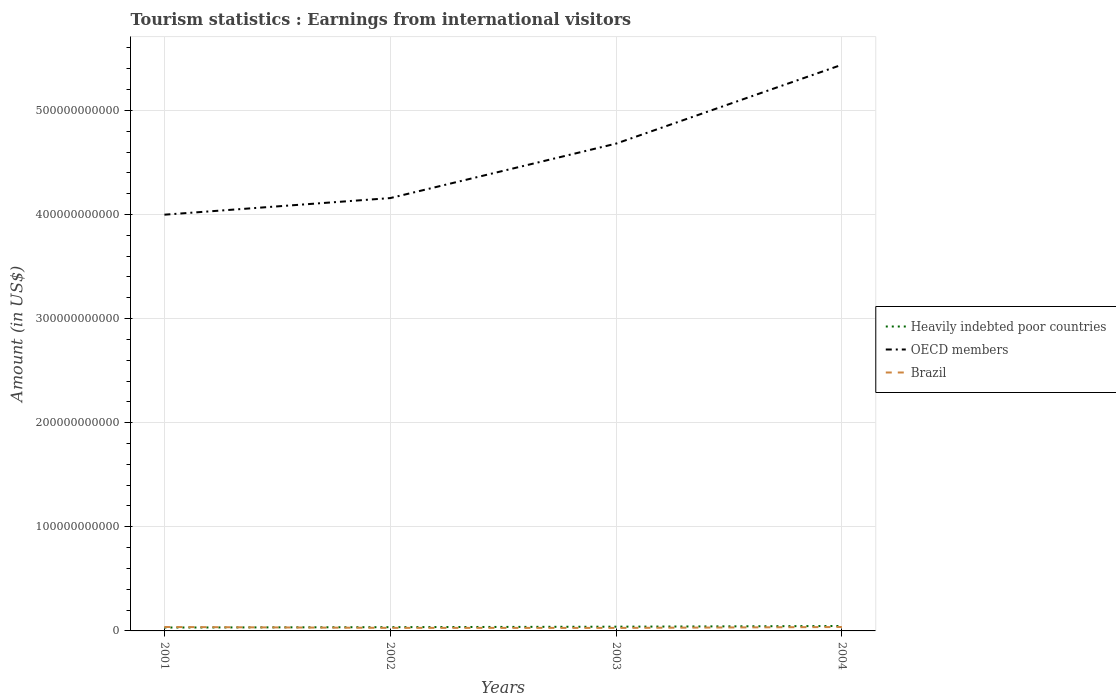How many different coloured lines are there?
Keep it short and to the point. 3. Does the line corresponding to Heavily indebted poor countries intersect with the line corresponding to Brazil?
Keep it short and to the point. Yes. Is the number of lines equal to the number of legend labels?
Your response must be concise. Yes. Across all years, what is the maximum earnings from international visitors in OECD members?
Give a very brief answer. 4.00e+11. What is the total earnings from international visitors in Heavily indebted poor countries in the graph?
Make the answer very short. -6.52e+08. What is the difference between the highest and the second highest earnings from international visitors in OECD members?
Your answer should be very brief. 1.44e+11. Is the earnings from international visitors in Brazil strictly greater than the earnings from international visitors in Heavily indebted poor countries over the years?
Your response must be concise. No. How many years are there in the graph?
Make the answer very short. 4. What is the difference between two consecutive major ticks on the Y-axis?
Offer a very short reply. 1.00e+11. Does the graph contain any zero values?
Your response must be concise. No. How many legend labels are there?
Keep it short and to the point. 3. What is the title of the graph?
Your answer should be compact. Tourism statistics : Earnings from international visitors. What is the label or title of the Y-axis?
Provide a succinct answer. Amount (in US$). What is the Amount (in US$) of Heavily indebted poor countries in 2001?
Your answer should be compact. 3.25e+09. What is the Amount (in US$) in OECD members in 2001?
Your answer should be very brief. 4.00e+11. What is the Amount (in US$) of Brazil in 2001?
Give a very brief answer. 3.76e+09. What is the Amount (in US$) in Heavily indebted poor countries in 2002?
Offer a terse response. 3.61e+09. What is the Amount (in US$) in OECD members in 2002?
Provide a short and direct response. 4.16e+11. What is the Amount (in US$) of Brazil in 2002?
Ensure brevity in your answer.  2.93e+09. What is the Amount (in US$) in Heavily indebted poor countries in 2003?
Your response must be concise. 4.07e+09. What is the Amount (in US$) of OECD members in 2003?
Your answer should be compact. 4.68e+11. What is the Amount (in US$) of Brazil in 2003?
Give a very brief answer. 2.87e+09. What is the Amount (in US$) in Heavily indebted poor countries in 2004?
Your answer should be compact. 4.72e+09. What is the Amount (in US$) of OECD members in 2004?
Your answer should be compact. 5.44e+11. What is the Amount (in US$) of Brazil in 2004?
Make the answer very short. 3.75e+09. Across all years, what is the maximum Amount (in US$) in Heavily indebted poor countries?
Provide a succinct answer. 4.72e+09. Across all years, what is the maximum Amount (in US$) of OECD members?
Give a very brief answer. 5.44e+11. Across all years, what is the maximum Amount (in US$) in Brazil?
Offer a terse response. 3.76e+09. Across all years, what is the minimum Amount (in US$) in Heavily indebted poor countries?
Give a very brief answer. 3.25e+09. Across all years, what is the minimum Amount (in US$) of OECD members?
Offer a terse response. 4.00e+11. Across all years, what is the minimum Amount (in US$) in Brazil?
Offer a very short reply. 2.87e+09. What is the total Amount (in US$) of Heavily indebted poor countries in the graph?
Your answer should be very brief. 1.57e+1. What is the total Amount (in US$) of OECD members in the graph?
Provide a short and direct response. 1.83e+12. What is the total Amount (in US$) in Brazil in the graph?
Offer a terse response. 1.33e+1. What is the difference between the Amount (in US$) of Heavily indebted poor countries in 2001 and that in 2002?
Provide a short and direct response. -3.57e+08. What is the difference between the Amount (in US$) in OECD members in 2001 and that in 2002?
Provide a succinct answer. -1.60e+1. What is the difference between the Amount (in US$) of Brazil in 2001 and that in 2002?
Make the answer very short. 8.36e+08. What is the difference between the Amount (in US$) in Heavily indebted poor countries in 2001 and that in 2003?
Keep it short and to the point. -8.21e+08. What is the difference between the Amount (in US$) of OECD members in 2001 and that in 2003?
Your response must be concise. -6.83e+1. What is the difference between the Amount (in US$) in Brazil in 2001 and that in 2003?
Your response must be concise. 8.91e+08. What is the difference between the Amount (in US$) of Heavily indebted poor countries in 2001 and that in 2004?
Your response must be concise. -1.47e+09. What is the difference between the Amount (in US$) in OECD members in 2001 and that in 2004?
Give a very brief answer. -1.44e+11. What is the difference between the Amount (in US$) of Brazil in 2001 and that in 2004?
Give a very brief answer. 1.30e+07. What is the difference between the Amount (in US$) of Heavily indebted poor countries in 2002 and that in 2003?
Provide a short and direct response. -4.64e+08. What is the difference between the Amount (in US$) of OECD members in 2002 and that in 2003?
Provide a succinct answer. -5.23e+1. What is the difference between the Amount (in US$) of Brazil in 2002 and that in 2003?
Offer a very short reply. 5.50e+07. What is the difference between the Amount (in US$) in Heavily indebted poor countries in 2002 and that in 2004?
Offer a very short reply. -1.12e+09. What is the difference between the Amount (in US$) in OECD members in 2002 and that in 2004?
Keep it short and to the point. -1.28e+11. What is the difference between the Amount (in US$) of Brazil in 2002 and that in 2004?
Your response must be concise. -8.23e+08. What is the difference between the Amount (in US$) in Heavily indebted poor countries in 2003 and that in 2004?
Provide a succinct answer. -6.52e+08. What is the difference between the Amount (in US$) of OECD members in 2003 and that in 2004?
Your answer should be very brief. -7.58e+1. What is the difference between the Amount (in US$) in Brazil in 2003 and that in 2004?
Your answer should be compact. -8.78e+08. What is the difference between the Amount (in US$) in Heavily indebted poor countries in 2001 and the Amount (in US$) in OECD members in 2002?
Ensure brevity in your answer.  -4.13e+11. What is the difference between the Amount (in US$) in Heavily indebted poor countries in 2001 and the Amount (in US$) in Brazil in 2002?
Provide a succinct answer. 3.22e+08. What is the difference between the Amount (in US$) of OECD members in 2001 and the Amount (in US$) of Brazil in 2002?
Provide a succinct answer. 3.97e+11. What is the difference between the Amount (in US$) of Heavily indebted poor countries in 2001 and the Amount (in US$) of OECD members in 2003?
Ensure brevity in your answer.  -4.65e+11. What is the difference between the Amount (in US$) of Heavily indebted poor countries in 2001 and the Amount (in US$) of Brazil in 2003?
Your response must be concise. 3.77e+08. What is the difference between the Amount (in US$) in OECD members in 2001 and the Amount (in US$) in Brazil in 2003?
Your answer should be very brief. 3.97e+11. What is the difference between the Amount (in US$) in Heavily indebted poor countries in 2001 and the Amount (in US$) in OECD members in 2004?
Provide a short and direct response. -5.41e+11. What is the difference between the Amount (in US$) in Heavily indebted poor countries in 2001 and the Amount (in US$) in Brazil in 2004?
Keep it short and to the point. -5.01e+08. What is the difference between the Amount (in US$) of OECD members in 2001 and the Amount (in US$) of Brazil in 2004?
Offer a very short reply. 3.96e+11. What is the difference between the Amount (in US$) in Heavily indebted poor countries in 2002 and the Amount (in US$) in OECD members in 2003?
Keep it short and to the point. -4.64e+11. What is the difference between the Amount (in US$) in Heavily indebted poor countries in 2002 and the Amount (in US$) in Brazil in 2003?
Make the answer very short. 7.34e+08. What is the difference between the Amount (in US$) of OECD members in 2002 and the Amount (in US$) of Brazil in 2003?
Your answer should be very brief. 4.13e+11. What is the difference between the Amount (in US$) in Heavily indebted poor countries in 2002 and the Amount (in US$) in OECD members in 2004?
Your response must be concise. -5.40e+11. What is the difference between the Amount (in US$) of Heavily indebted poor countries in 2002 and the Amount (in US$) of Brazil in 2004?
Offer a very short reply. -1.44e+08. What is the difference between the Amount (in US$) in OECD members in 2002 and the Amount (in US$) in Brazil in 2004?
Make the answer very short. 4.12e+11. What is the difference between the Amount (in US$) in Heavily indebted poor countries in 2003 and the Amount (in US$) in OECD members in 2004?
Give a very brief answer. -5.40e+11. What is the difference between the Amount (in US$) of Heavily indebted poor countries in 2003 and the Amount (in US$) of Brazil in 2004?
Your answer should be compact. 3.20e+08. What is the difference between the Amount (in US$) in OECD members in 2003 and the Amount (in US$) in Brazil in 2004?
Make the answer very short. 4.64e+11. What is the average Amount (in US$) of Heavily indebted poor countries per year?
Ensure brevity in your answer.  3.91e+09. What is the average Amount (in US$) in OECD members per year?
Ensure brevity in your answer.  4.57e+11. What is the average Amount (in US$) in Brazil per year?
Offer a very short reply. 3.33e+09. In the year 2001, what is the difference between the Amount (in US$) in Heavily indebted poor countries and Amount (in US$) in OECD members?
Give a very brief answer. -3.97e+11. In the year 2001, what is the difference between the Amount (in US$) in Heavily indebted poor countries and Amount (in US$) in Brazil?
Make the answer very short. -5.14e+08. In the year 2001, what is the difference between the Amount (in US$) in OECD members and Amount (in US$) in Brazil?
Keep it short and to the point. 3.96e+11. In the year 2002, what is the difference between the Amount (in US$) in Heavily indebted poor countries and Amount (in US$) in OECD members?
Give a very brief answer. -4.12e+11. In the year 2002, what is the difference between the Amount (in US$) of Heavily indebted poor countries and Amount (in US$) of Brazil?
Provide a succinct answer. 6.79e+08. In the year 2002, what is the difference between the Amount (in US$) in OECD members and Amount (in US$) in Brazil?
Give a very brief answer. 4.13e+11. In the year 2003, what is the difference between the Amount (in US$) in Heavily indebted poor countries and Amount (in US$) in OECD members?
Give a very brief answer. -4.64e+11. In the year 2003, what is the difference between the Amount (in US$) of Heavily indebted poor countries and Amount (in US$) of Brazil?
Your answer should be very brief. 1.20e+09. In the year 2003, what is the difference between the Amount (in US$) of OECD members and Amount (in US$) of Brazil?
Your answer should be compact. 4.65e+11. In the year 2004, what is the difference between the Amount (in US$) in Heavily indebted poor countries and Amount (in US$) in OECD members?
Provide a succinct answer. -5.39e+11. In the year 2004, what is the difference between the Amount (in US$) in Heavily indebted poor countries and Amount (in US$) in Brazil?
Offer a terse response. 9.72e+08. In the year 2004, what is the difference between the Amount (in US$) of OECD members and Amount (in US$) of Brazil?
Your answer should be very brief. 5.40e+11. What is the ratio of the Amount (in US$) in Heavily indebted poor countries in 2001 to that in 2002?
Keep it short and to the point. 0.9. What is the ratio of the Amount (in US$) of OECD members in 2001 to that in 2002?
Make the answer very short. 0.96. What is the ratio of the Amount (in US$) of Brazil in 2001 to that in 2002?
Your answer should be compact. 1.29. What is the ratio of the Amount (in US$) in Heavily indebted poor countries in 2001 to that in 2003?
Offer a terse response. 0.8. What is the ratio of the Amount (in US$) in OECD members in 2001 to that in 2003?
Your answer should be compact. 0.85. What is the ratio of the Amount (in US$) of Brazil in 2001 to that in 2003?
Keep it short and to the point. 1.31. What is the ratio of the Amount (in US$) in Heavily indebted poor countries in 2001 to that in 2004?
Give a very brief answer. 0.69. What is the ratio of the Amount (in US$) of OECD members in 2001 to that in 2004?
Your answer should be compact. 0.74. What is the ratio of the Amount (in US$) in Heavily indebted poor countries in 2002 to that in 2003?
Your answer should be very brief. 0.89. What is the ratio of the Amount (in US$) of OECD members in 2002 to that in 2003?
Provide a succinct answer. 0.89. What is the ratio of the Amount (in US$) in Brazil in 2002 to that in 2003?
Make the answer very short. 1.02. What is the ratio of the Amount (in US$) in Heavily indebted poor countries in 2002 to that in 2004?
Your answer should be very brief. 0.76. What is the ratio of the Amount (in US$) of OECD members in 2002 to that in 2004?
Your answer should be compact. 0.76. What is the ratio of the Amount (in US$) of Brazil in 2002 to that in 2004?
Ensure brevity in your answer.  0.78. What is the ratio of the Amount (in US$) in Heavily indebted poor countries in 2003 to that in 2004?
Your answer should be compact. 0.86. What is the ratio of the Amount (in US$) in OECD members in 2003 to that in 2004?
Give a very brief answer. 0.86. What is the ratio of the Amount (in US$) of Brazil in 2003 to that in 2004?
Your answer should be very brief. 0.77. What is the difference between the highest and the second highest Amount (in US$) of Heavily indebted poor countries?
Your response must be concise. 6.52e+08. What is the difference between the highest and the second highest Amount (in US$) in OECD members?
Give a very brief answer. 7.58e+1. What is the difference between the highest and the second highest Amount (in US$) of Brazil?
Offer a very short reply. 1.30e+07. What is the difference between the highest and the lowest Amount (in US$) in Heavily indebted poor countries?
Make the answer very short. 1.47e+09. What is the difference between the highest and the lowest Amount (in US$) of OECD members?
Make the answer very short. 1.44e+11. What is the difference between the highest and the lowest Amount (in US$) in Brazil?
Provide a succinct answer. 8.91e+08. 